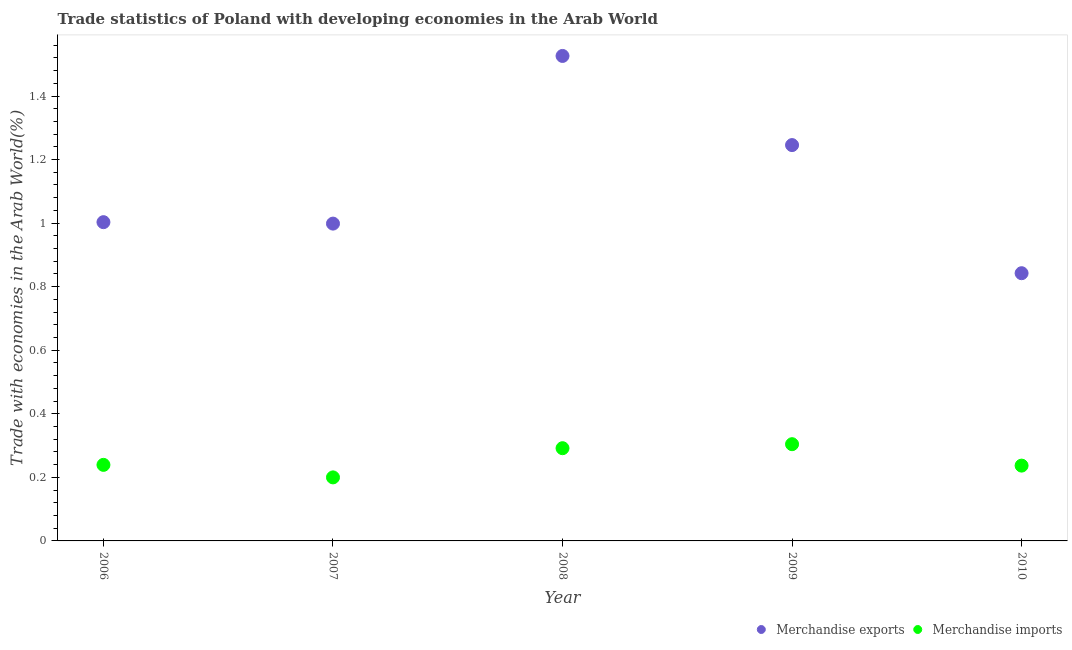What is the merchandise imports in 2007?
Make the answer very short. 0.2. Across all years, what is the maximum merchandise exports?
Ensure brevity in your answer.  1.53. Across all years, what is the minimum merchandise imports?
Your answer should be compact. 0.2. In which year was the merchandise imports maximum?
Give a very brief answer. 2009. What is the total merchandise imports in the graph?
Offer a terse response. 1.27. What is the difference between the merchandise exports in 2006 and that in 2007?
Give a very brief answer. 0. What is the difference between the merchandise imports in 2007 and the merchandise exports in 2006?
Give a very brief answer. -0.8. What is the average merchandise imports per year?
Your answer should be compact. 0.25. In the year 2010, what is the difference between the merchandise imports and merchandise exports?
Your response must be concise. -0.61. In how many years, is the merchandise exports greater than 0.8 %?
Offer a very short reply. 5. What is the ratio of the merchandise imports in 2007 to that in 2009?
Provide a short and direct response. 0.66. Is the merchandise imports in 2007 less than that in 2009?
Your answer should be very brief. Yes. Is the difference between the merchandise exports in 2007 and 2009 greater than the difference between the merchandise imports in 2007 and 2009?
Your answer should be compact. No. What is the difference between the highest and the second highest merchandise exports?
Offer a very short reply. 0.28. What is the difference between the highest and the lowest merchandise imports?
Your answer should be very brief. 0.1. In how many years, is the merchandise imports greater than the average merchandise imports taken over all years?
Your answer should be compact. 2. Is the merchandise exports strictly greater than the merchandise imports over the years?
Your answer should be compact. Yes. Is the merchandise imports strictly less than the merchandise exports over the years?
Keep it short and to the point. Yes. What is the difference between two consecutive major ticks on the Y-axis?
Provide a short and direct response. 0.2. Are the values on the major ticks of Y-axis written in scientific E-notation?
Make the answer very short. No. Does the graph contain any zero values?
Your answer should be very brief. No. Where does the legend appear in the graph?
Provide a short and direct response. Bottom right. How are the legend labels stacked?
Offer a terse response. Horizontal. What is the title of the graph?
Keep it short and to the point. Trade statistics of Poland with developing economies in the Arab World. Does "Resident workers" appear as one of the legend labels in the graph?
Your response must be concise. No. What is the label or title of the X-axis?
Your answer should be compact. Year. What is the label or title of the Y-axis?
Offer a very short reply. Trade with economies in the Arab World(%). What is the Trade with economies in the Arab World(%) of Merchandise exports in 2006?
Your response must be concise. 1. What is the Trade with economies in the Arab World(%) of Merchandise imports in 2006?
Make the answer very short. 0.24. What is the Trade with economies in the Arab World(%) in Merchandise exports in 2007?
Keep it short and to the point. 1. What is the Trade with economies in the Arab World(%) in Merchandise imports in 2007?
Offer a terse response. 0.2. What is the Trade with economies in the Arab World(%) of Merchandise exports in 2008?
Ensure brevity in your answer.  1.53. What is the Trade with economies in the Arab World(%) in Merchandise imports in 2008?
Your response must be concise. 0.29. What is the Trade with economies in the Arab World(%) of Merchandise exports in 2009?
Your answer should be very brief. 1.25. What is the Trade with economies in the Arab World(%) of Merchandise imports in 2009?
Offer a very short reply. 0.3. What is the Trade with economies in the Arab World(%) of Merchandise exports in 2010?
Give a very brief answer. 0.84. What is the Trade with economies in the Arab World(%) of Merchandise imports in 2010?
Provide a succinct answer. 0.24. Across all years, what is the maximum Trade with economies in the Arab World(%) in Merchandise exports?
Your response must be concise. 1.53. Across all years, what is the maximum Trade with economies in the Arab World(%) of Merchandise imports?
Make the answer very short. 0.3. Across all years, what is the minimum Trade with economies in the Arab World(%) of Merchandise exports?
Your answer should be very brief. 0.84. Across all years, what is the minimum Trade with economies in the Arab World(%) of Merchandise imports?
Offer a terse response. 0.2. What is the total Trade with economies in the Arab World(%) of Merchandise exports in the graph?
Give a very brief answer. 5.62. What is the total Trade with economies in the Arab World(%) of Merchandise imports in the graph?
Provide a short and direct response. 1.27. What is the difference between the Trade with economies in the Arab World(%) in Merchandise exports in 2006 and that in 2007?
Offer a very short reply. 0. What is the difference between the Trade with economies in the Arab World(%) of Merchandise imports in 2006 and that in 2007?
Keep it short and to the point. 0.04. What is the difference between the Trade with economies in the Arab World(%) of Merchandise exports in 2006 and that in 2008?
Offer a very short reply. -0.52. What is the difference between the Trade with economies in the Arab World(%) in Merchandise imports in 2006 and that in 2008?
Offer a very short reply. -0.05. What is the difference between the Trade with economies in the Arab World(%) in Merchandise exports in 2006 and that in 2009?
Your answer should be compact. -0.24. What is the difference between the Trade with economies in the Arab World(%) of Merchandise imports in 2006 and that in 2009?
Make the answer very short. -0.07. What is the difference between the Trade with economies in the Arab World(%) of Merchandise exports in 2006 and that in 2010?
Keep it short and to the point. 0.16. What is the difference between the Trade with economies in the Arab World(%) in Merchandise imports in 2006 and that in 2010?
Provide a succinct answer. 0. What is the difference between the Trade with economies in the Arab World(%) in Merchandise exports in 2007 and that in 2008?
Provide a succinct answer. -0.53. What is the difference between the Trade with economies in the Arab World(%) of Merchandise imports in 2007 and that in 2008?
Your answer should be very brief. -0.09. What is the difference between the Trade with economies in the Arab World(%) in Merchandise exports in 2007 and that in 2009?
Make the answer very short. -0.25. What is the difference between the Trade with economies in the Arab World(%) in Merchandise imports in 2007 and that in 2009?
Offer a terse response. -0.1. What is the difference between the Trade with economies in the Arab World(%) of Merchandise exports in 2007 and that in 2010?
Provide a succinct answer. 0.16. What is the difference between the Trade with economies in the Arab World(%) of Merchandise imports in 2007 and that in 2010?
Provide a succinct answer. -0.04. What is the difference between the Trade with economies in the Arab World(%) in Merchandise exports in 2008 and that in 2009?
Provide a succinct answer. 0.28. What is the difference between the Trade with economies in the Arab World(%) of Merchandise imports in 2008 and that in 2009?
Provide a short and direct response. -0.01. What is the difference between the Trade with economies in the Arab World(%) in Merchandise exports in 2008 and that in 2010?
Offer a very short reply. 0.68. What is the difference between the Trade with economies in the Arab World(%) in Merchandise imports in 2008 and that in 2010?
Your answer should be very brief. 0.05. What is the difference between the Trade with economies in the Arab World(%) of Merchandise exports in 2009 and that in 2010?
Offer a terse response. 0.4. What is the difference between the Trade with economies in the Arab World(%) in Merchandise imports in 2009 and that in 2010?
Make the answer very short. 0.07. What is the difference between the Trade with economies in the Arab World(%) of Merchandise exports in 2006 and the Trade with economies in the Arab World(%) of Merchandise imports in 2007?
Make the answer very short. 0.8. What is the difference between the Trade with economies in the Arab World(%) in Merchandise exports in 2006 and the Trade with economies in the Arab World(%) in Merchandise imports in 2008?
Your answer should be compact. 0.71. What is the difference between the Trade with economies in the Arab World(%) of Merchandise exports in 2006 and the Trade with economies in the Arab World(%) of Merchandise imports in 2009?
Keep it short and to the point. 0.7. What is the difference between the Trade with economies in the Arab World(%) in Merchandise exports in 2006 and the Trade with economies in the Arab World(%) in Merchandise imports in 2010?
Offer a terse response. 0.77. What is the difference between the Trade with economies in the Arab World(%) of Merchandise exports in 2007 and the Trade with economies in the Arab World(%) of Merchandise imports in 2008?
Keep it short and to the point. 0.71. What is the difference between the Trade with economies in the Arab World(%) in Merchandise exports in 2007 and the Trade with economies in the Arab World(%) in Merchandise imports in 2009?
Keep it short and to the point. 0.69. What is the difference between the Trade with economies in the Arab World(%) in Merchandise exports in 2007 and the Trade with economies in the Arab World(%) in Merchandise imports in 2010?
Offer a very short reply. 0.76. What is the difference between the Trade with economies in the Arab World(%) in Merchandise exports in 2008 and the Trade with economies in the Arab World(%) in Merchandise imports in 2009?
Your answer should be compact. 1.22. What is the difference between the Trade with economies in the Arab World(%) of Merchandise exports in 2008 and the Trade with economies in the Arab World(%) of Merchandise imports in 2010?
Make the answer very short. 1.29. What is the difference between the Trade with economies in the Arab World(%) in Merchandise exports in 2009 and the Trade with economies in the Arab World(%) in Merchandise imports in 2010?
Provide a succinct answer. 1.01. What is the average Trade with economies in the Arab World(%) in Merchandise exports per year?
Provide a succinct answer. 1.12. What is the average Trade with economies in the Arab World(%) in Merchandise imports per year?
Make the answer very short. 0.25. In the year 2006, what is the difference between the Trade with economies in the Arab World(%) in Merchandise exports and Trade with economies in the Arab World(%) in Merchandise imports?
Provide a succinct answer. 0.76. In the year 2007, what is the difference between the Trade with economies in the Arab World(%) in Merchandise exports and Trade with economies in the Arab World(%) in Merchandise imports?
Your response must be concise. 0.8. In the year 2008, what is the difference between the Trade with economies in the Arab World(%) of Merchandise exports and Trade with economies in the Arab World(%) of Merchandise imports?
Offer a very short reply. 1.23. In the year 2009, what is the difference between the Trade with economies in the Arab World(%) of Merchandise exports and Trade with economies in the Arab World(%) of Merchandise imports?
Make the answer very short. 0.94. In the year 2010, what is the difference between the Trade with economies in the Arab World(%) in Merchandise exports and Trade with economies in the Arab World(%) in Merchandise imports?
Provide a short and direct response. 0.61. What is the ratio of the Trade with economies in the Arab World(%) in Merchandise imports in 2006 to that in 2007?
Ensure brevity in your answer.  1.2. What is the ratio of the Trade with economies in the Arab World(%) of Merchandise exports in 2006 to that in 2008?
Provide a succinct answer. 0.66. What is the ratio of the Trade with economies in the Arab World(%) of Merchandise imports in 2006 to that in 2008?
Your response must be concise. 0.82. What is the ratio of the Trade with economies in the Arab World(%) in Merchandise exports in 2006 to that in 2009?
Give a very brief answer. 0.81. What is the ratio of the Trade with economies in the Arab World(%) of Merchandise imports in 2006 to that in 2009?
Your answer should be compact. 0.79. What is the ratio of the Trade with economies in the Arab World(%) in Merchandise exports in 2006 to that in 2010?
Offer a very short reply. 1.19. What is the ratio of the Trade with economies in the Arab World(%) in Merchandise imports in 2006 to that in 2010?
Keep it short and to the point. 1.01. What is the ratio of the Trade with economies in the Arab World(%) of Merchandise exports in 2007 to that in 2008?
Offer a terse response. 0.65. What is the ratio of the Trade with economies in the Arab World(%) of Merchandise imports in 2007 to that in 2008?
Keep it short and to the point. 0.69. What is the ratio of the Trade with economies in the Arab World(%) in Merchandise exports in 2007 to that in 2009?
Offer a very short reply. 0.8. What is the ratio of the Trade with economies in the Arab World(%) in Merchandise imports in 2007 to that in 2009?
Offer a terse response. 0.66. What is the ratio of the Trade with economies in the Arab World(%) of Merchandise exports in 2007 to that in 2010?
Offer a terse response. 1.19. What is the ratio of the Trade with economies in the Arab World(%) of Merchandise imports in 2007 to that in 2010?
Give a very brief answer. 0.84. What is the ratio of the Trade with economies in the Arab World(%) of Merchandise exports in 2008 to that in 2009?
Your answer should be very brief. 1.23. What is the ratio of the Trade with economies in the Arab World(%) of Merchandise imports in 2008 to that in 2009?
Keep it short and to the point. 0.96. What is the ratio of the Trade with economies in the Arab World(%) of Merchandise exports in 2008 to that in 2010?
Provide a short and direct response. 1.81. What is the ratio of the Trade with economies in the Arab World(%) of Merchandise imports in 2008 to that in 2010?
Offer a terse response. 1.23. What is the ratio of the Trade with economies in the Arab World(%) in Merchandise exports in 2009 to that in 2010?
Your answer should be very brief. 1.48. What is the ratio of the Trade with economies in the Arab World(%) in Merchandise imports in 2009 to that in 2010?
Keep it short and to the point. 1.28. What is the difference between the highest and the second highest Trade with economies in the Arab World(%) in Merchandise exports?
Your response must be concise. 0.28. What is the difference between the highest and the second highest Trade with economies in the Arab World(%) in Merchandise imports?
Provide a succinct answer. 0.01. What is the difference between the highest and the lowest Trade with economies in the Arab World(%) of Merchandise exports?
Offer a very short reply. 0.68. What is the difference between the highest and the lowest Trade with economies in the Arab World(%) of Merchandise imports?
Offer a terse response. 0.1. 